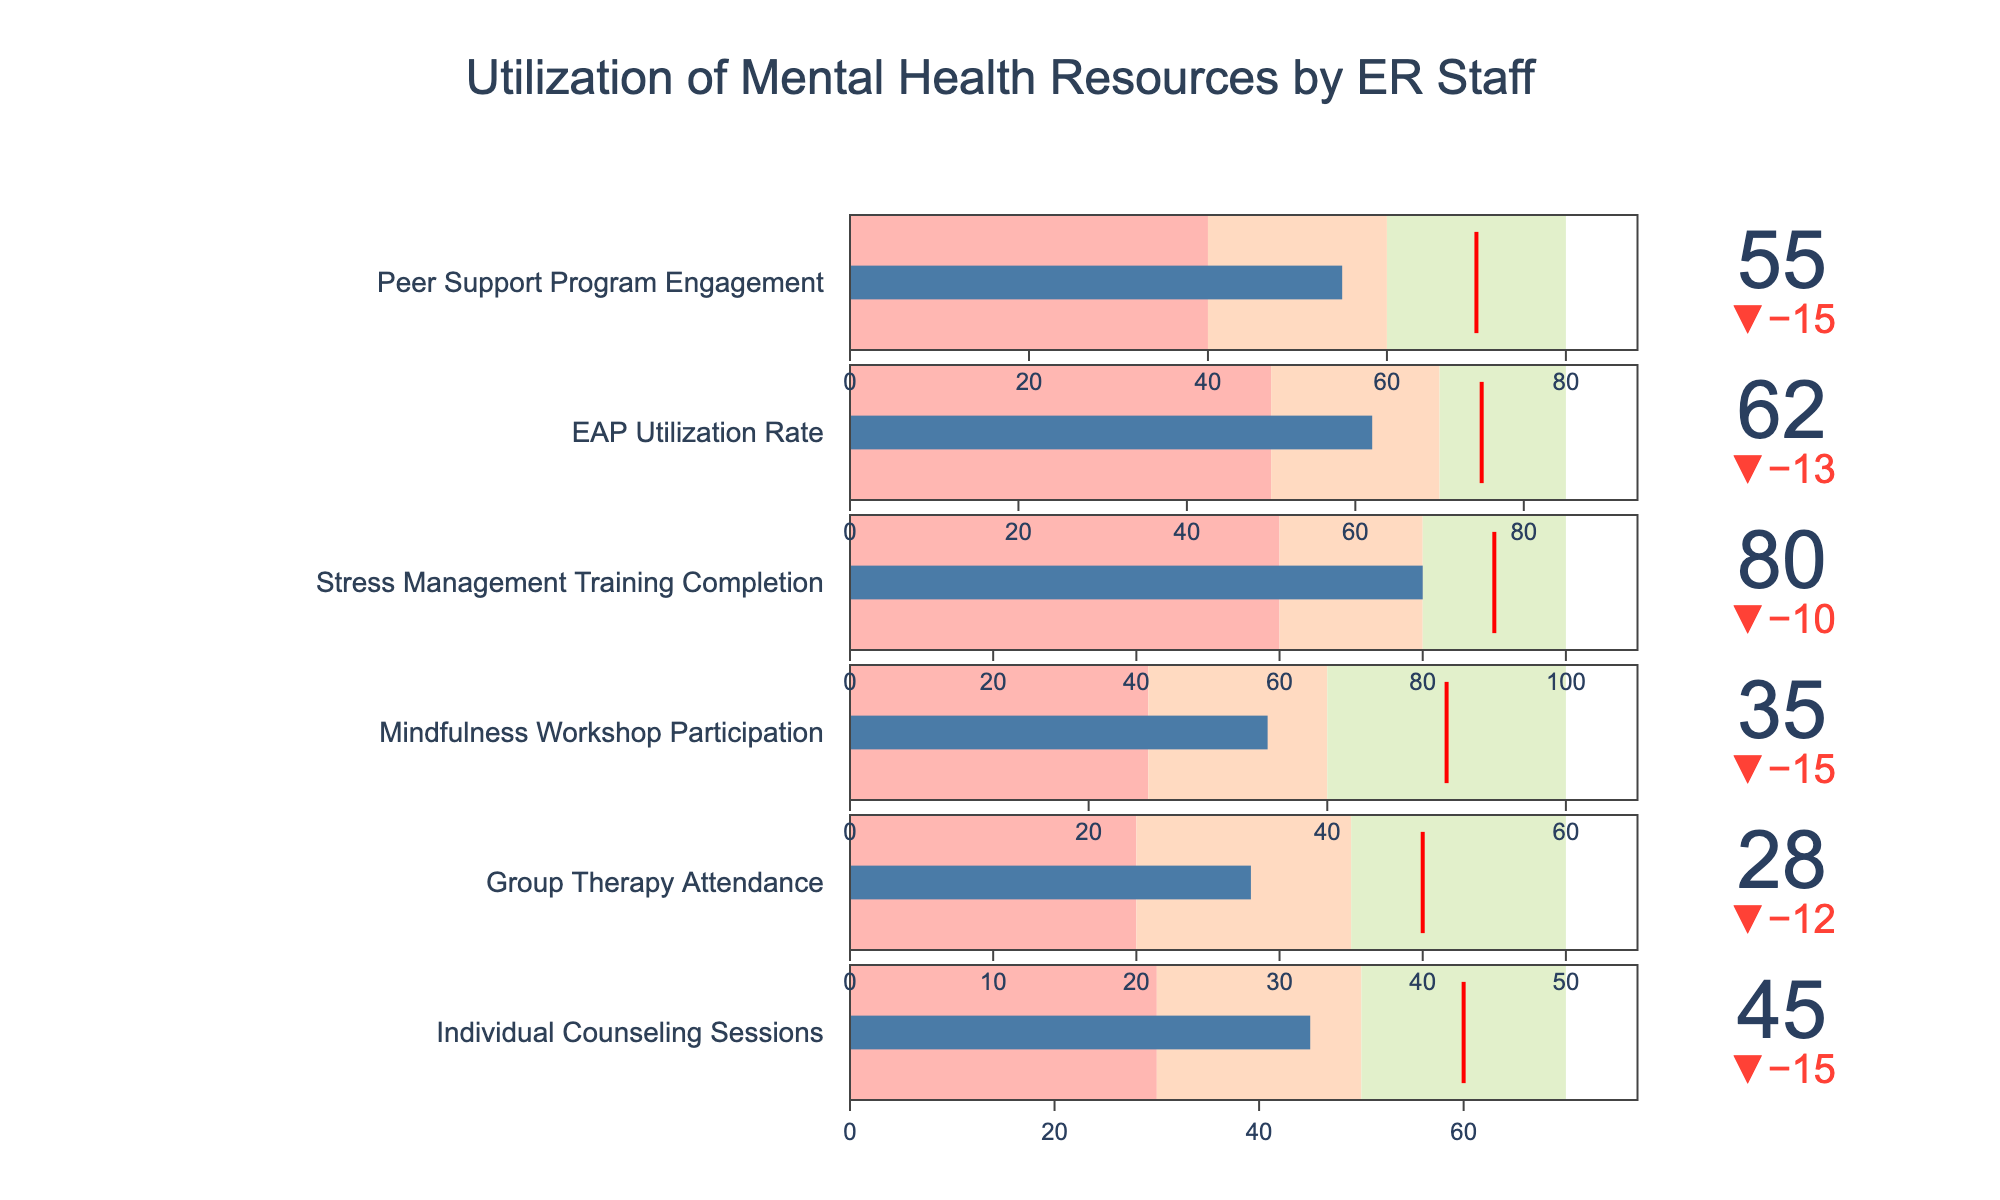What's the title of the figure? The title of the figure is located at the top of the chart and it provides an overview of the data being displayed.
Answer: Utilization of Mental Health Resources by ER Staff What is the actual utilization rate of Individual Counseling Sessions relative to the target? Identify the 'Actual' value and the 'Target' value for Individual Counseling Sessions and compare them. The actual utilization can be found under 'Actual', and the target utilization under 'Target'.
Answer: 45 out of 60 Which category has the highest actual value? Observe all the actual values of the categories in the chart and identify the highest one.
Answer: Stress Management Training Completion Is the actual value of Mindfulness Workshop Participation above or below the target? Compare the 'Actual' value of Mindfulness Workshop Participation with its 'Target' value.
Answer: Below By how much does the EAP Utilization Rate fall short of the target? Subtract the 'Actual' value of EAP Utilization Rate from its 'Target' value to find the shortfall.
Answer: 13 What percentage of the target was achieved for Group Therapy Attendance? Divide the actual value of Group Therapy Attendance by its target and multiply by 100 to get the percentage. 28/40 is the fraction to be multiplied by 100.
Answer: 70% Which two categories have the closest actual values? Compare the actual values of all categories and identify the two with the least difference.
Answer: Peer Support Program Engagement and Mindfulness Workshop Participation (55 and 35) What is the average actual utilization rate across all categories? Sum all the actual values and divide by the number of categories to get the average. The actual values sum to 305, divided by 6 categories.
Answer: 50.83 Which category has the furthest gap from satisfactory to very good? For each category, calculate the difference between 'Very Good' and 'Satisfactory' and identify the one with the greatest gap.
Answer: Stress Management Training Completion For Peer Support Program Engagement, how does the actual value compare to the poor, satisfactory, good, and very good ranges? Compare the actual value for Peer Support Program Engagement with the ranges provided for 'Poor', 'Satisfactory', 'Good', and 'Very Good'. The ranges are color-coded in the chart.
Answer: Between Satisfactory and Good 